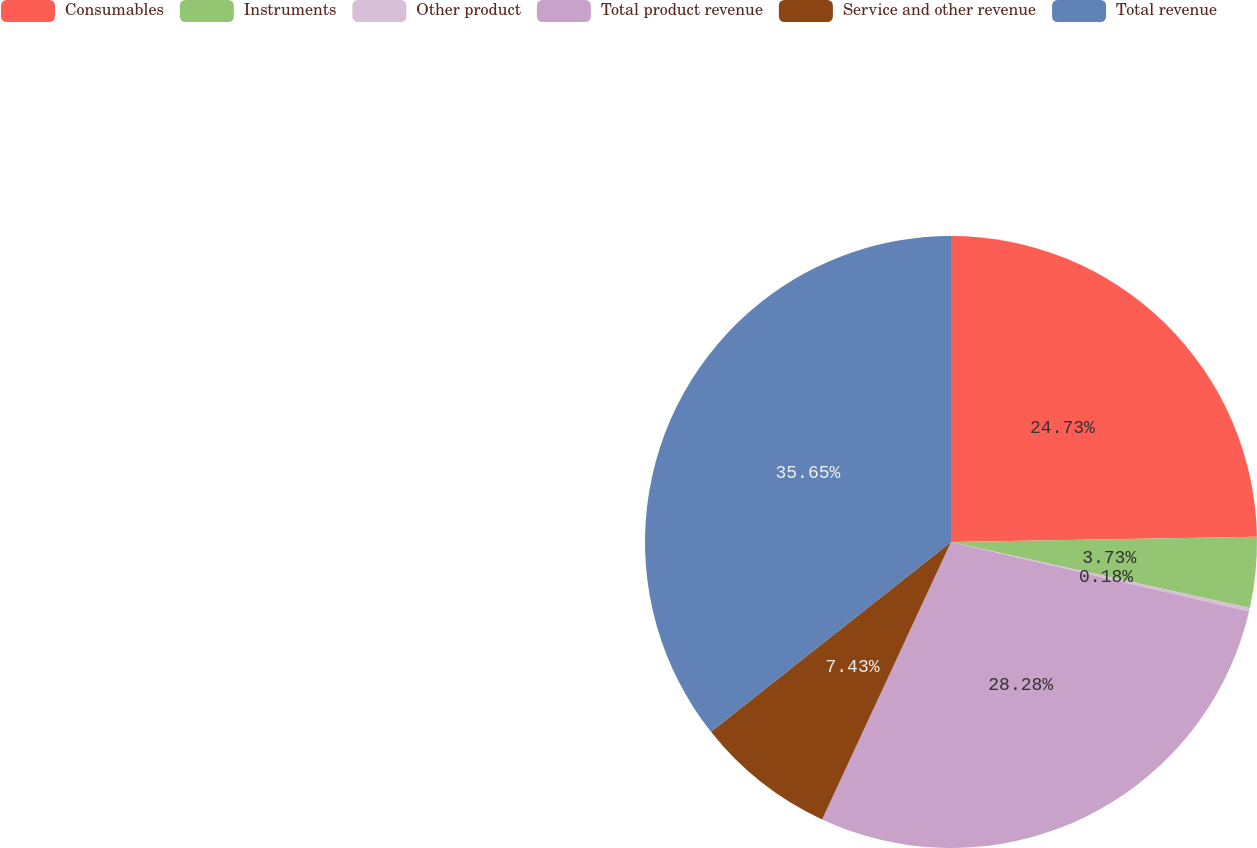Convert chart. <chart><loc_0><loc_0><loc_500><loc_500><pie_chart><fcel>Consumables<fcel>Instruments<fcel>Other product<fcel>Total product revenue<fcel>Service and other revenue<fcel>Total revenue<nl><fcel>24.73%<fcel>3.73%<fcel>0.18%<fcel>28.28%<fcel>7.43%<fcel>35.65%<nl></chart> 